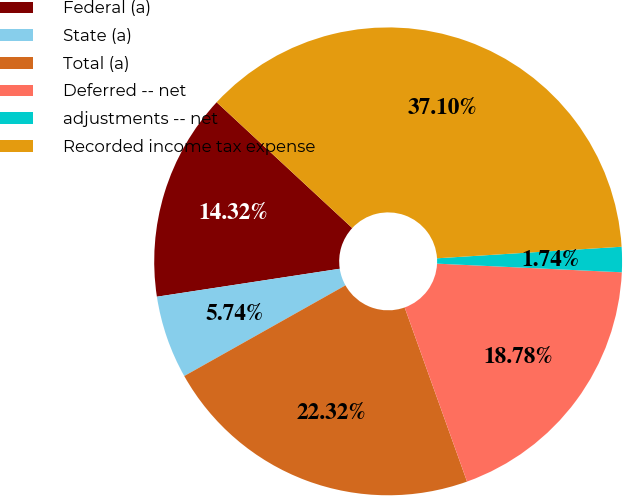Convert chart. <chart><loc_0><loc_0><loc_500><loc_500><pie_chart><fcel>Federal (a)<fcel>State (a)<fcel>Total (a)<fcel>Deferred -- net<fcel>adjustments -- net<fcel>Recorded income tax expense<nl><fcel>14.32%<fcel>5.74%<fcel>22.32%<fcel>18.78%<fcel>1.74%<fcel>37.1%<nl></chart> 